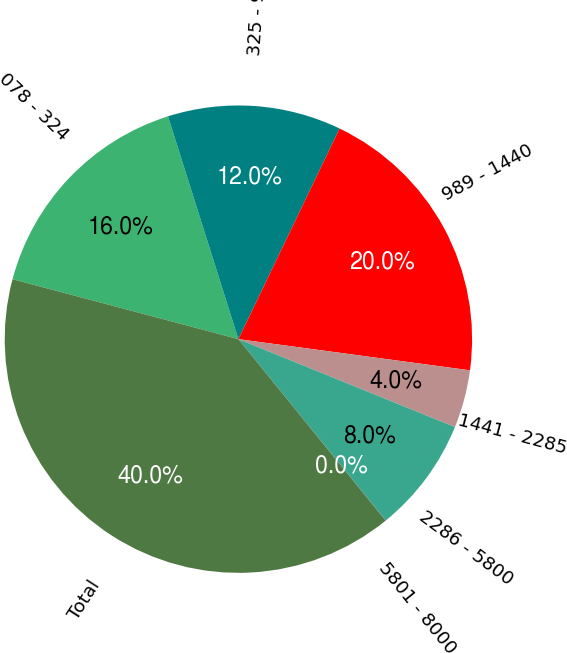Convert chart to OTSL. <chart><loc_0><loc_0><loc_500><loc_500><pie_chart><fcel>078 - 324<fcel>325 - 988<fcel>989 - 1440<fcel>1441 - 2285<fcel>2286 - 5800<fcel>5801 - 8000<fcel>Total<nl><fcel>16.0%<fcel>12.0%<fcel>20.0%<fcel>4.01%<fcel>8.0%<fcel>0.01%<fcel>39.98%<nl></chart> 